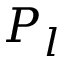Convert formula to latex. <formula><loc_0><loc_0><loc_500><loc_500>P _ { l }</formula> 